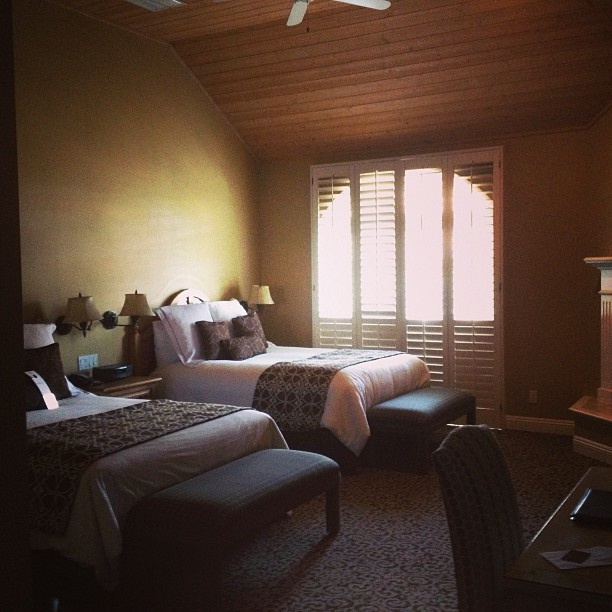Describe the objects in this image and their specific colors. I can see bed in black, gray, and darkgray tones, bed in black, gray, and lightgray tones, and chair in black and gray tones in this image. 